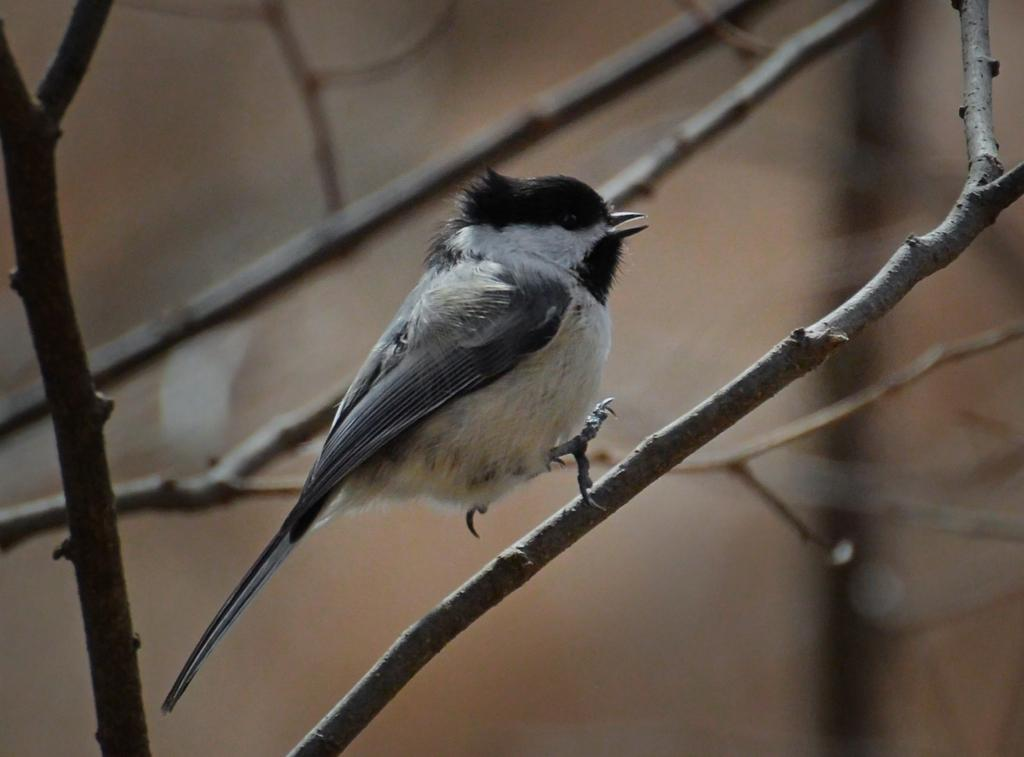What is the setting of the image? The image was likely taken outside. What is the main subject of the image? There is a bird on a stem in the center of the image. What can be seen around the bird? There are dry stems visible in the image. What else can be seen in the background of the image? There are other items in the background of the image. What position does the bird's uncle hold in the image? There is no bird's uncle present in the image, as the image features a bird on a stem and no other living beings. 